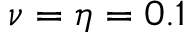<formula> <loc_0><loc_0><loc_500><loc_500>\nu = \eta = 0 . 1</formula> 